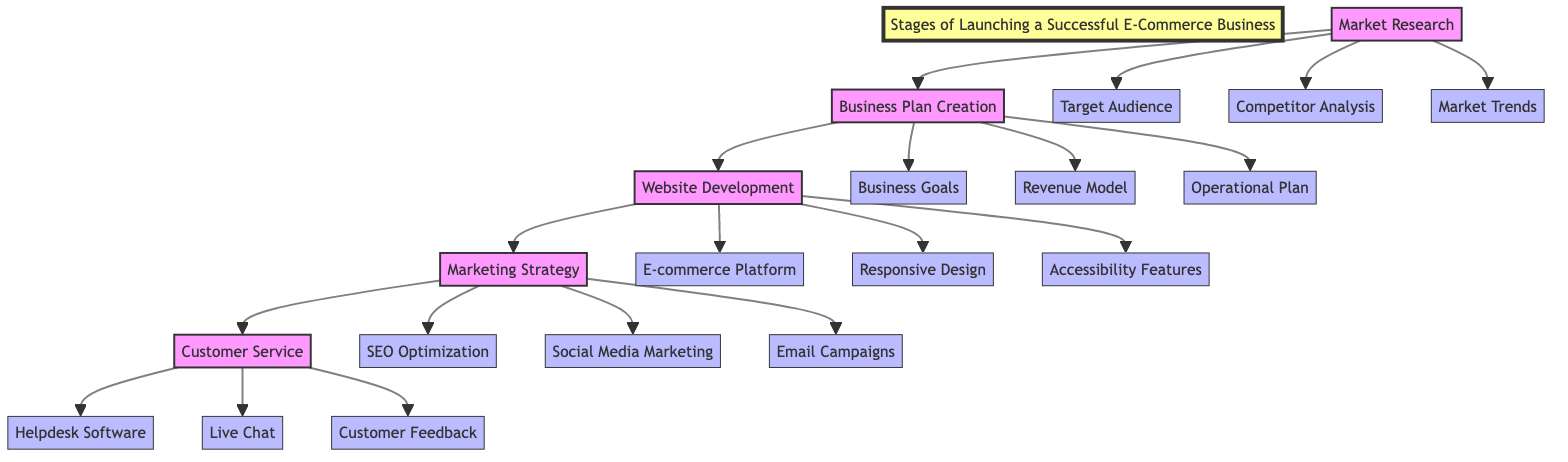What is the first stage in launching an e-commerce business? The diagram indicates that the first stage is labeled "Market Research." This can be identified as it is the initial node from which the entire flow of the diagram begins.
Answer: Market Research How many main stages are there in the diagram? By examining the diagram, there are five main stages (Market Research, Business Plan Creation, Website Development, Marketing Strategy, and Customer Service), which are clearly represented as separate nodes connected in a linear format.
Answer: 5 Which entity belongs to the "Business Plan Creation" stage? Looking at the connections, "Business Goals" is one of the entities that falls under the "Business Plan Creation" stage. The diagram has connecting arrows that direct from the Business Plan Creation node to the Business Goals node.
Answer: Business Goals What follows after "Website Development" in the flow? The diagram shows a direct arrow leading from "Website Development" to "Marketing Strategy," indicating that the next stage following Website Development is Marketing Strategy.
Answer: Marketing Strategy Which specific feature is included in the "Website Development" stage? The entities connected to the Website Development node include "E-commerce Platform," "Responsive Design," and "Accessibility Features." "Accessibility Features" specifically focuses on making the website usable for everyone, including those with disabilities.
Answer: Accessibility Features What are the components of the "Customer Service" stage? The diagram has three entities linked to the Customer Service node: "Helpdesk Software," "Live Chat," and "Customer Feedback." Each of these entities serves as a component of the overall customer service strategy.
Answer: Helpdesk Software, Live Chat, Customer Feedback How does "Market Research" connect to "Competitive Analysis"? The diagram indicates that "Market Research" branches out to multiple entities, including "Competitor Analysis." This shows that competitor analysis is a specific component of the broader market research stage.
Answer: Competitor Analysis What is the last stage represented in the diagram? The final node with no arrows leading out indicates that the end of the stage progression is "Customer Service." It comes after all previous stages and serves as the concluding focus of the process.
Answer: Customer Service Which marketing strategy component is listed in the diagram? In the Marketing Strategy stage, "SEO Optimization," "Social Media Marketing," and "Email Campaigns" are all components. One specific example from this list is "SEO Optimization."
Answer: SEO Optimization 